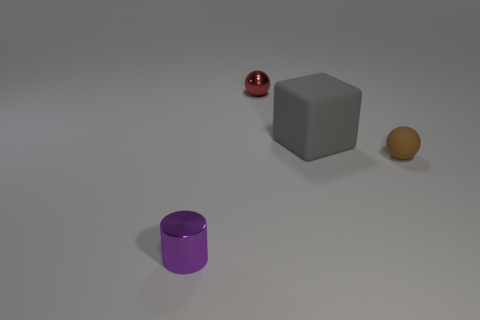Add 2 cylinders. How many objects exist? 6 Subtract all blocks. How many objects are left? 3 Add 3 tiny brown balls. How many tiny brown balls exist? 4 Subtract 1 purple cylinders. How many objects are left? 3 Subtract all large gray matte blocks. Subtract all small metallic blocks. How many objects are left? 3 Add 1 small brown things. How many small brown things are left? 2 